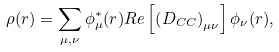Convert formula to latex. <formula><loc_0><loc_0><loc_500><loc_500>\rho ( r ) = \sum _ { \mu , \nu } \phi ^ { * } _ { \mu } ( r ) R e \left [ \left ( D _ { C C } \right ) _ { \mu \nu } \right ] \phi _ { \nu } ( r ) ,</formula> 